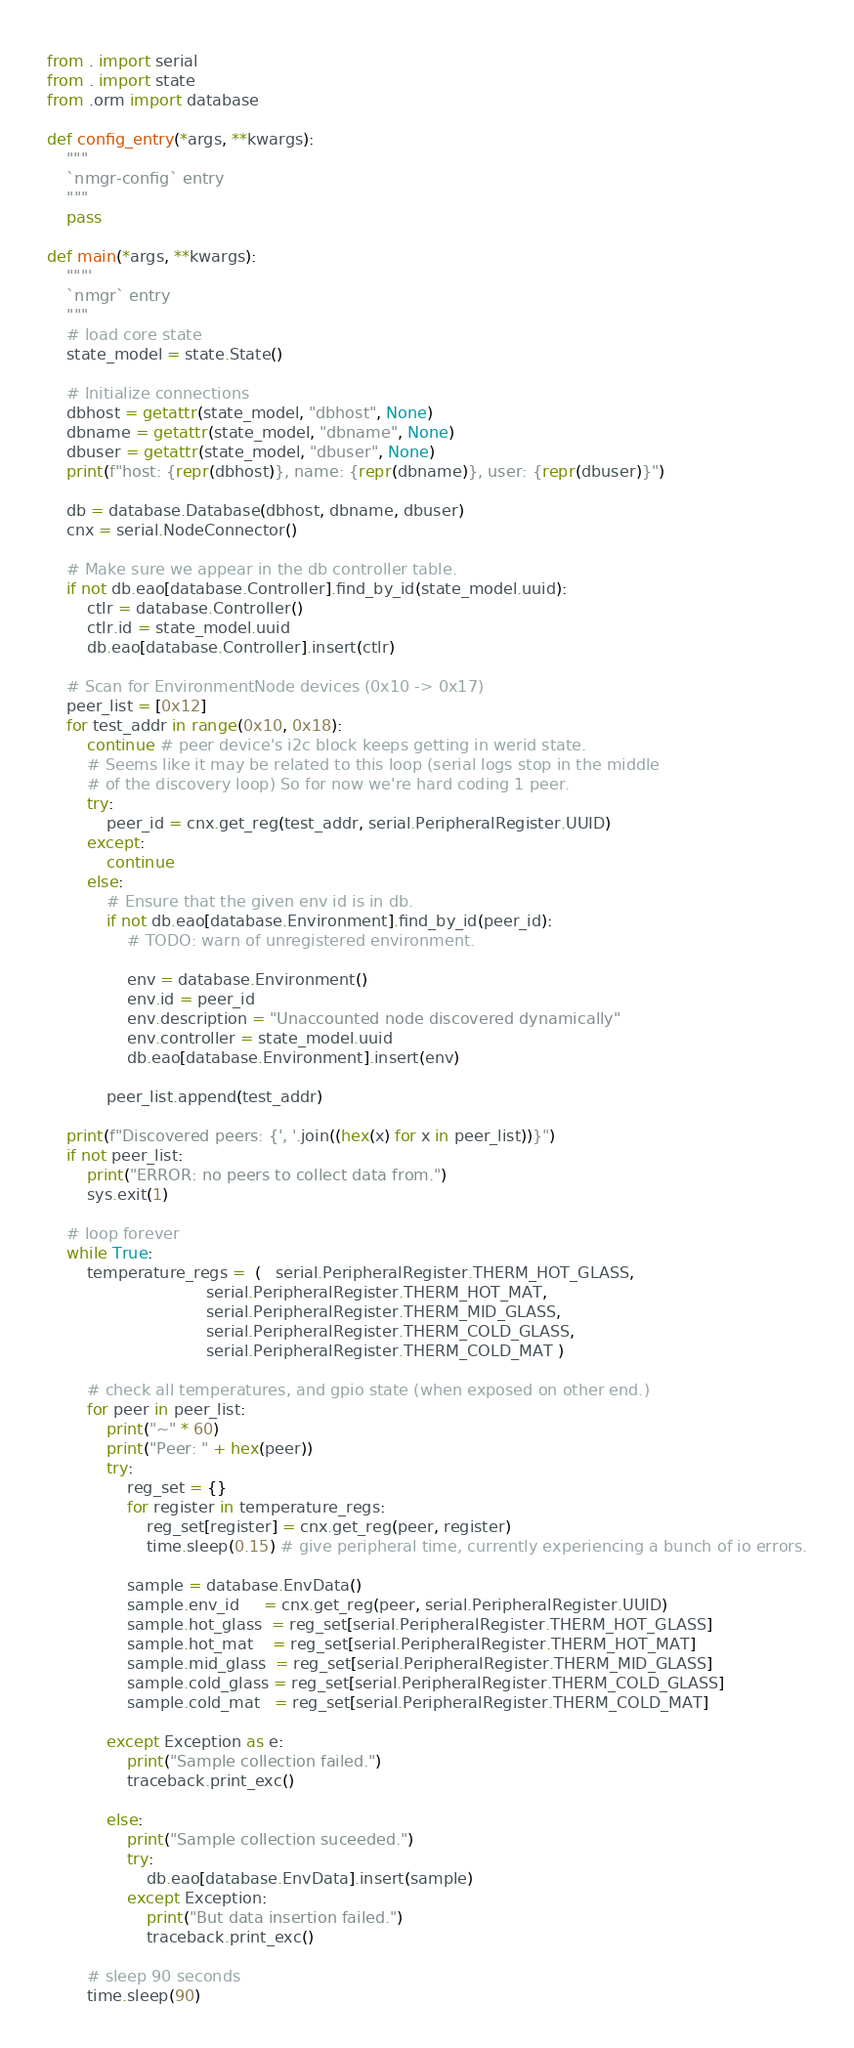Convert code to text. <code><loc_0><loc_0><loc_500><loc_500><_Python_>
from . import serial
from . import state
from .orm import database

def config_entry(*args, **kwargs):
    """
    `nmgr-config` entry
    """
    pass

def main(*args, **kwargs):
    """'
    `nmgr` entry
    """
    # load core state
    state_model = state.State()

    # Initialize connections
    dbhost = getattr(state_model, "dbhost", None)
    dbname = getattr(state_model, "dbname", None)
    dbuser = getattr(state_model, "dbuser", None)
    print(f"host: {repr(dbhost)}, name: {repr(dbname)}, user: {repr(dbuser)}")

    db = database.Database(dbhost, dbname, dbuser)
    cnx = serial.NodeConnector()

    # Make sure we appear in the db controller table.
    if not db.eao[database.Controller].find_by_id(state_model.uuid):
        ctlr = database.Controller()
        ctlr.id = state_model.uuid
        db.eao[database.Controller].insert(ctlr)

    # Scan for EnvironmentNode devices (0x10 -> 0x17)
    peer_list = [0x12]
    for test_addr in range(0x10, 0x18):
        continue # peer device's i2c block keeps getting in werid state.
        # Seems like it may be related to this loop (serial logs stop in the middle
        # of the discovery loop) So for now we're hard coding 1 peer.
        try:
            peer_id = cnx.get_reg(test_addr, serial.PeripheralRegister.UUID)
        except:
            continue
        else:
            # Ensure that the given env id is in db.
            if not db.eao[database.Environment].find_by_id(peer_id):
                # TODO: warn of unregistered environment.

                env = database.Environment()
                env.id = peer_id
                env.description = "Unaccounted node discovered dynamically"
                env.controller = state_model.uuid
                db.eao[database.Environment].insert(env)

            peer_list.append(test_addr)

    print(f"Discovered peers: {', '.join((hex(x) for x in peer_list))}")
    if not peer_list:
        print("ERROR: no peers to collect data from.")
        sys.exit(1)

    # loop forever
    while True:
        temperature_regs =  (   serial.PeripheralRegister.THERM_HOT_GLASS,
                                serial.PeripheralRegister.THERM_HOT_MAT,
                                serial.PeripheralRegister.THERM_MID_GLASS,
                                serial.PeripheralRegister.THERM_COLD_GLASS,
                                serial.PeripheralRegister.THERM_COLD_MAT )

        # check all temperatures, and gpio state (when exposed on other end.)
        for peer in peer_list:
            print("~" * 60)
            print("Peer: " + hex(peer))
            try:
                reg_set = {}
                for register in temperature_regs:
                    reg_set[register] = cnx.get_reg(peer, register)
                    time.sleep(0.15) # give peripheral time, currently experiencing a bunch of io errors.

                sample = database.EnvData()
                sample.env_id     = cnx.get_reg(peer, serial.PeripheralRegister.UUID)
                sample.hot_glass  = reg_set[serial.PeripheralRegister.THERM_HOT_GLASS]
                sample.hot_mat    = reg_set[serial.PeripheralRegister.THERM_HOT_MAT]
                sample.mid_glass  = reg_set[serial.PeripheralRegister.THERM_MID_GLASS]
                sample.cold_glass = reg_set[serial.PeripheralRegister.THERM_COLD_GLASS]
                sample.cold_mat   = reg_set[serial.PeripheralRegister.THERM_COLD_MAT]

            except Exception as e:
                print("Sample collection failed.")
                traceback.print_exc()

            else:
                print("Sample collection suceeded.")
                try:
                    db.eao[database.EnvData].insert(sample)
                except Exception:
                    print("But data insertion failed.")
                    traceback.print_exc()

        # sleep 90 seconds
        time.sleep(90)
</code> 